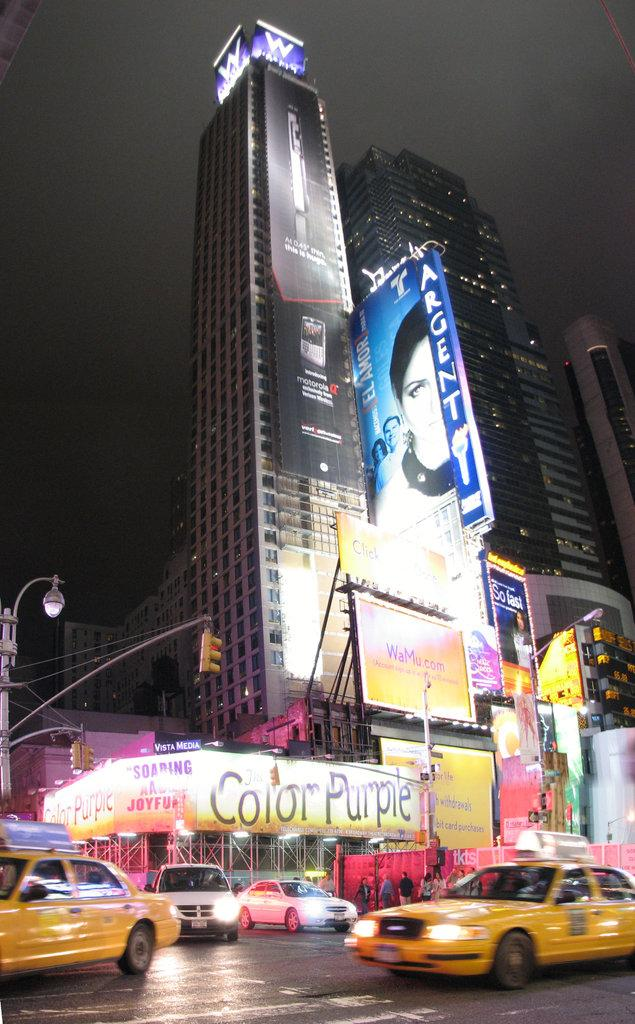<image>
Render a clear and concise summary of the photo. A busy city intersection near a sign for the Color Purple. 